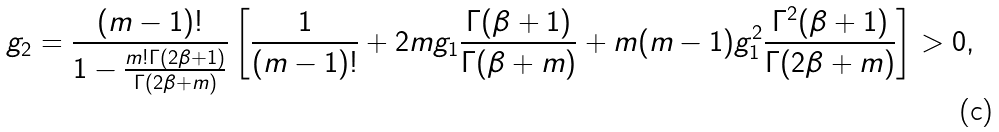Convert formula to latex. <formula><loc_0><loc_0><loc_500><loc_500>g _ { 2 } = \frac { ( m - 1 ) ! } { 1 - \frac { m ! \Gamma ( 2 \beta + 1 ) } { \Gamma ( 2 \beta + m ) } } \left [ \frac { 1 } { ( m - 1 ) ! } + 2 m g _ { 1 } \frac { \Gamma ( \beta + 1 ) } { \Gamma ( \beta + m ) } + m ( m - 1 ) g _ { 1 } ^ { 2 } \frac { \Gamma ^ { 2 } ( \beta + 1 ) } { \Gamma ( 2 \beta + m ) } \right ] > 0 ,</formula> 